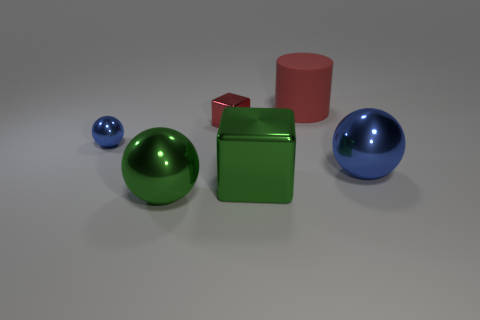What is the green sphere made of?
Offer a very short reply. Metal. What number of objects are tiny red shiny blocks or small green rubber cylinders?
Provide a short and direct response. 1. There is a blue sphere that is to the right of the tiny blue shiny object; is it the same size as the red thing on the right side of the green block?
Offer a terse response. Yes. What number of other objects are the same size as the red block?
Give a very brief answer. 1. How many things are either big objects on the right side of the big matte thing or shiny spheres on the right side of the tiny red metal cube?
Offer a terse response. 1. Do the cylinder and the big green object that is to the left of the tiny metallic block have the same material?
Offer a very short reply. No. What number of other things are there of the same shape as the red matte thing?
Your response must be concise. 0. There is a big object in front of the metallic cube in front of the blue object that is left of the big blue shiny sphere; what is it made of?
Your response must be concise. Metal. Is the number of tiny red blocks behind the red shiny cube the same as the number of big cyan rubber blocks?
Provide a short and direct response. Yes. Is the material of the blue sphere left of the large blue ball the same as the thing right of the rubber cylinder?
Make the answer very short. Yes. 